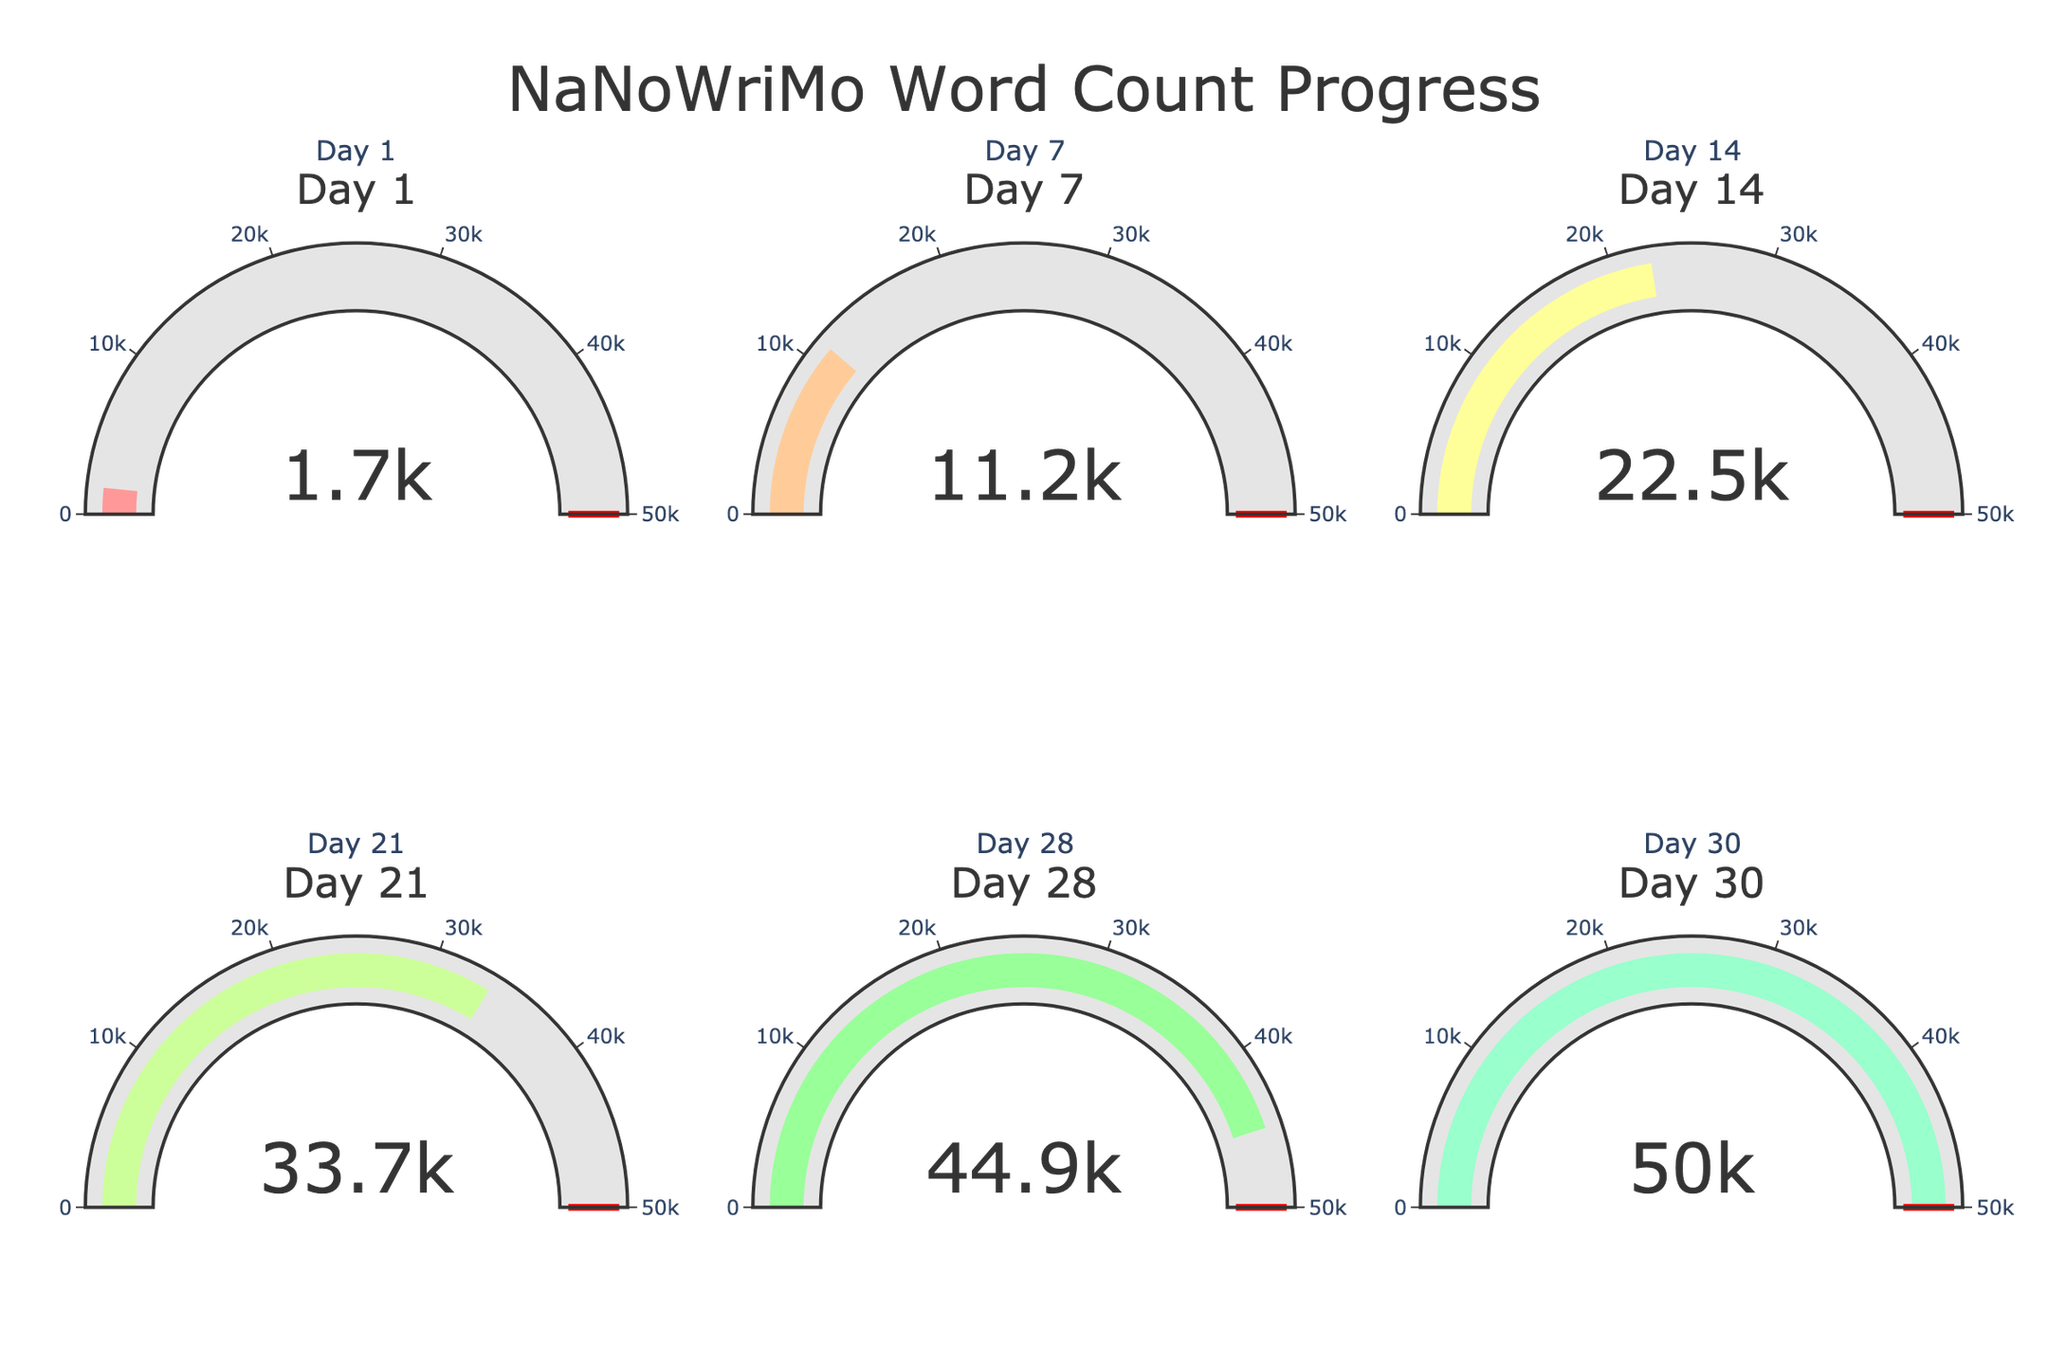What's the title of the figure? The title is prominently displayed at the top of the figure in a large font size and reads "NaNoWriMo Word Count Progress".
Answer: NaNoWriMo Word Count Progress How many days are represented in the plot? The subplot titles and gauges are labeled for each day, with six gauges corresponding to six distinct days.
Answer: 6 What is the word count on Day 30? The gauge labeled "Day 30" displays the word count, which is 50,000.
Answer: 50,000 What's the difference in word count between Day 28 and Day 30? By examining the gauges for Day 28 and Day 30, we see that the word counts are 44,936 and 50,000, respectively. The difference is 50,000 - 44,936.
Answer: 5,064 What is the average word count from Day 1 to Day 30? To find the average, sum the word counts for Day 1 (1,654), Day 7 (11,235), Day 14 (22,468), Day 21 (33,702), Day 28 (44,936), and Day 30 (50,000), then divide by 6: (1,654 + 11,235 + 22,468 + 33,702 + 44,936 + 50,000) / 6.
Answer: 27,332.5 By how much did the word count increase between Day 1 and Day 14? The word count on Day 1 is 1,654, and on Day 14 it is 22,468. Subtract the former from the latter: 22,468 - 1,654.
Answer: 20,814 Which day has the lowest word count? By comparing the gauges for all six days, Day 1 has the lowest word count, displayed as 1,654.
Answer: Day 1 Is the word count on Day 7 greater than or less than double of Day 1? The word count on Day 7 is 11,235. Double the word count on Day 1 (1,654) is 3,308. Since 11,235 is greater than 3,308, the word count on Day 7 is more than double Day 1.
Answer: Greater By what percentage of the goal is the word count on Day 21? The word count on Day 21 is 33,702. The goal is 50,000. To find the percentage: (33,702 / 50,000) * 100.
Answer: 67.4% Which day shows a word count threshold line (red) at the goal value? The threshold line is shown reaching the goal value on all six days as each gauge is designed to have a red line denoting the goal of 50,000 words.
Answer: All days 